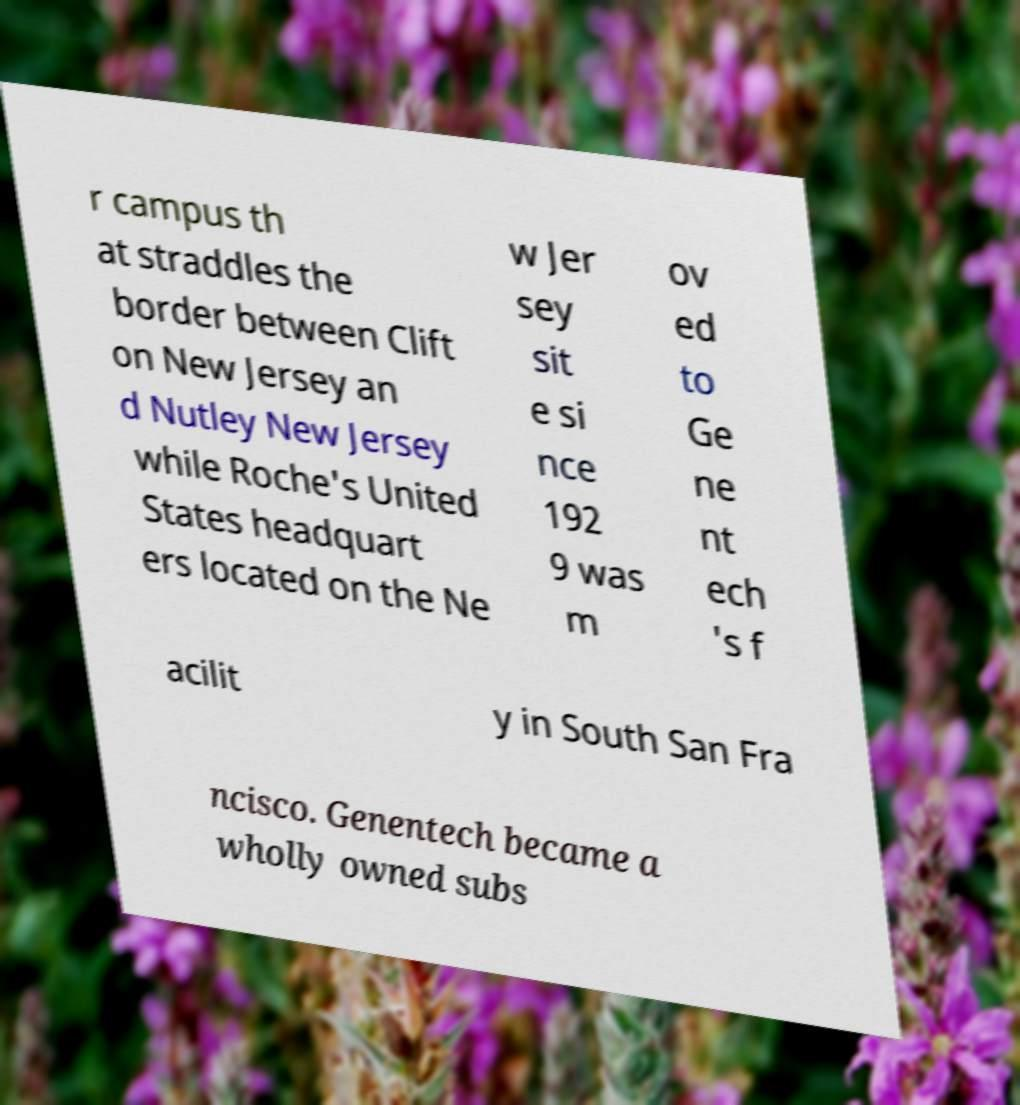For documentation purposes, I need the text within this image transcribed. Could you provide that? r campus th at straddles the border between Clift on New Jersey an d Nutley New Jersey while Roche's United States headquart ers located on the Ne w Jer sey sit e si nce 192 9 was m ov ed to Ge ne nt ech 's f acilit y in South San Fra ncisco. Genentech became a wholly owned subs 